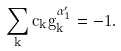Convert formula to latex. <formula><loc_0><loc_0><loc_500><loc_500>\sum _ { k } c _ { k } g _ { k } ^ { \alpha ^ { \prime } _ { 1 } } = - 1 .</formula> 